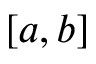Convert formula to latex. <formula><loc_0><loc_0><loc_500><loc_500>[ a , b ]</formula> 